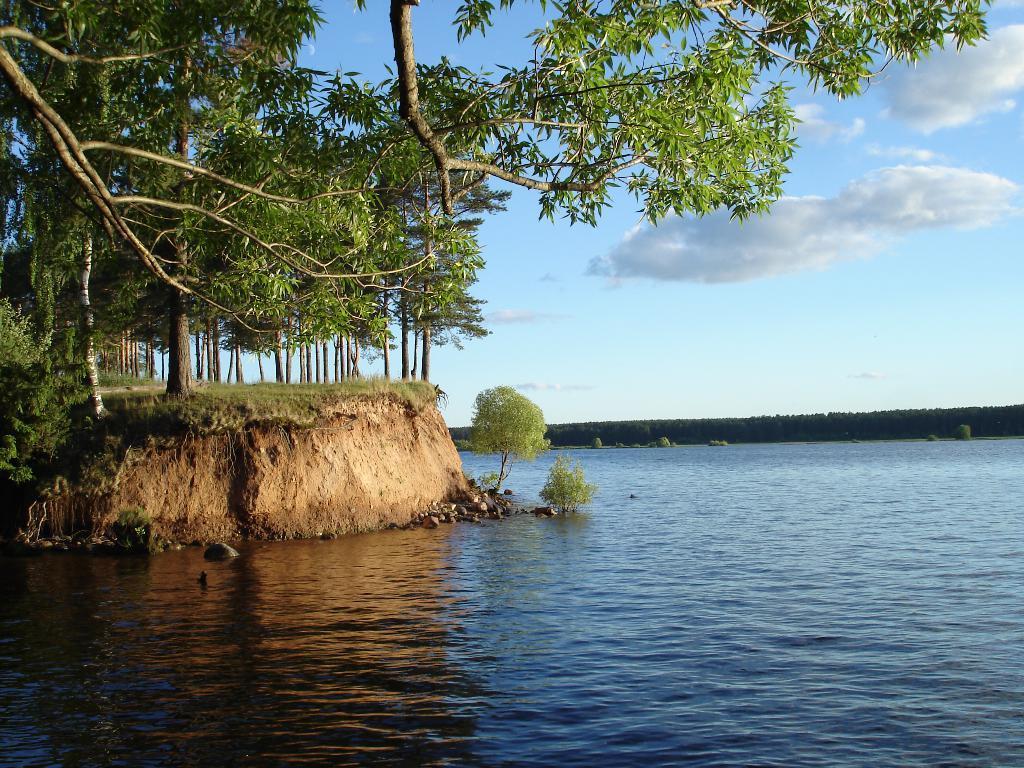How would you summarize this image in a sentence or two? In this image I can see the water, few plants, the ground, and few trees. In the background I can see few trees and the sky. 